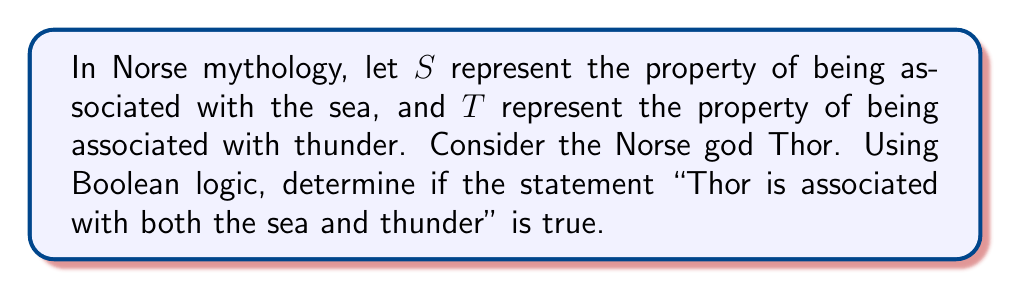Could you help me with this problem? Let's approach this step-by-step using Boolean algebra:

1) First, we need to determine the truth values for $S$ and $T$ for Thor:
   
   $S$ (associated with the sea): False (0)
   $T$ (associated with thunder): True (1)

2) The statement "Thor is associated with both the sea and thunder" can be represented as a Boolean AND operation:

   $S \land T$

3) In Boolean algebra, the AND operation is true only if both inputs are true. We can represent this with a truth table:

   $$
   \begin{array}{|c|c|c|}
   \hline
   S & T & S \land T \\
   \hline
   0 & 0 & 0 \\
   0 & 1 & 0 \\
   1 & 0 & 0 \\
   1 & 1 & 1 \\
   \hline
   \end{array}
   $$

4) For Thor, we have $S = 0$ and $T = 1$. Looking at the truth table, we can see that when $S = 0$ and $T = 1$, $S \land T = 0$.

5) Therefore, the statement "Thor is associated with both the sea and thunder" is false in Boolean logic.
Answer: False 